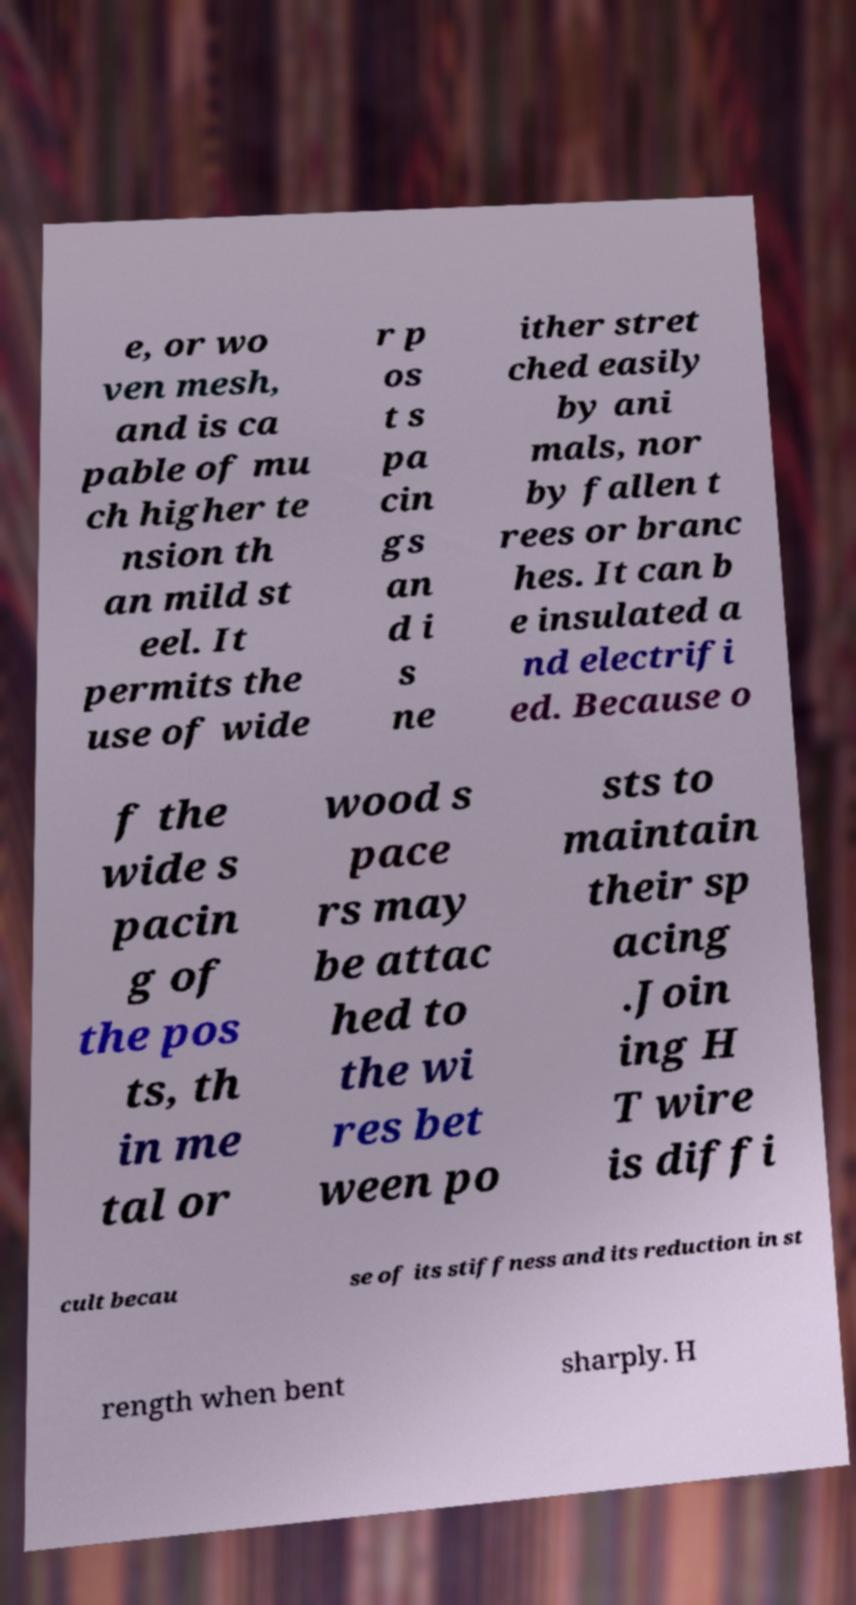Can you read and provide the text displayed in the image?This photo seems to have some interesting text. Can you extract and type it out for me? e, or wo ven mesh, and is ca pable of mu ch higher te nsion th an mild st eel. It permits the use of wide r p os t s pa cin gs an d i s ne ither stret ched easily by ani mals, nor by fallen t rees or branc hes. It can b e insulated a nd electrifi ed. Because o f the wide s pacin g of the pos ts, th in me tal or wood s pace rs may be attac hed to the wi res bet ween po sts to maintain their sp acing .Join ing H T wire is diffi cult becau se of its stiffness and its reduction in st rength when bent sharply. H 